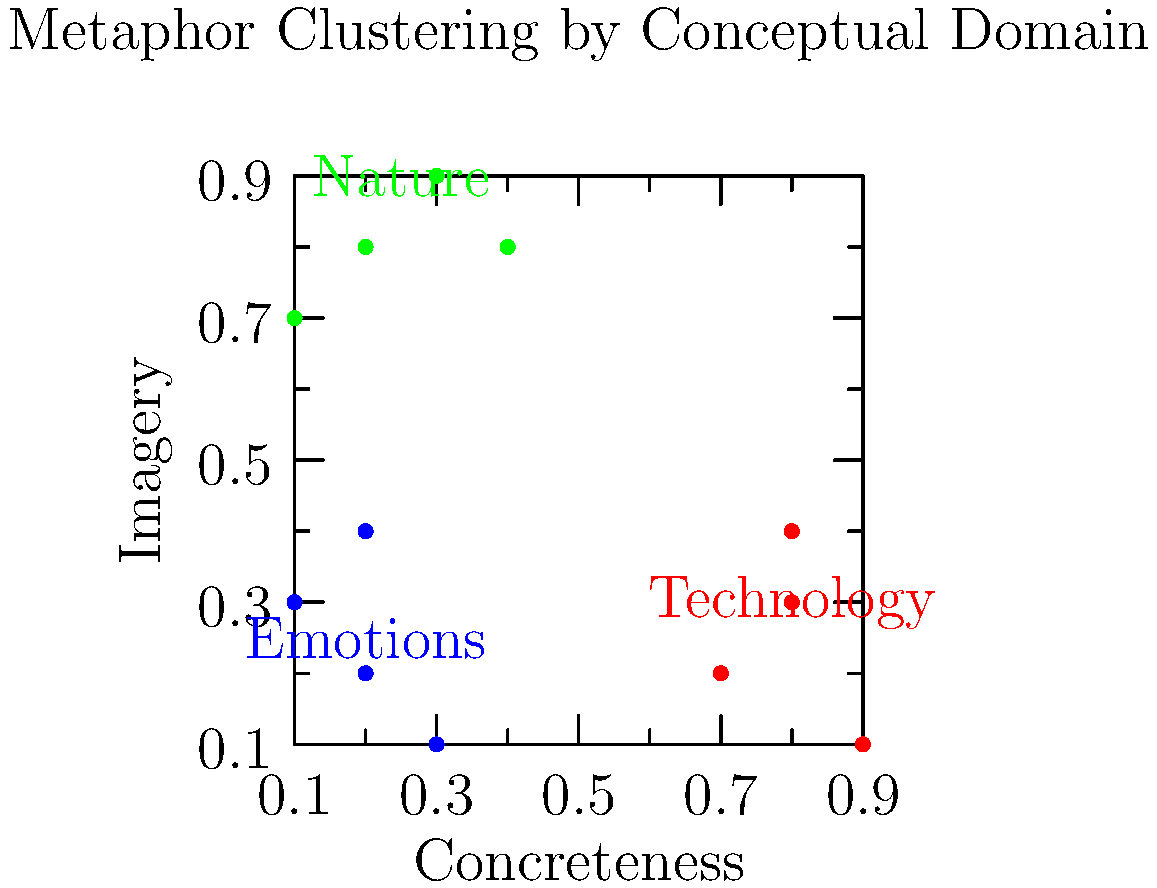Analyze the scatter plot depicting metaphor clustering based on conceptual domains. Which domain shows the highest degree of imagery and concreteness, and what might this suggest about the nature of metaphors in this domain? To answer this question, we need to examine the scatter plot and interpret the data points for each conceptual domain:

1. Identify the axes:
   - X-axis represents Concreteness
   - Y-axis represents Imagery

2. Locate the clusters:
   - Green cluster (top-left): Nature
   - Red cluster (bottom-right): Technology
   - Blue cluster (bottom-left): Emotions

3. Analyze the positioning of each cluster:
   - Nature: High imagery, relatively low concreteness
   - Technology: High concreteness, relatively low imagery
   - Emotions: Low in both imagery and concreteness

4. Determine the domain with highest imagery and concreteness:
   - Nature has the highest imagery
   - Technology has the highest concreteness
   - Neither domain scores highest in both dimensions simultaneously

5. Interpret the findings:
   - Nature metaphors tend to be highly visual but less tangible
   - Technology metaphors are more concrete but less imagistic
   - The nature domain shows the highest overall combination of imagery and concreteness

6. Consider the implications:
   - Nature metaphors may be more vivid and easier to visualize
   - This could suggest that nature-based metaphors are particularly effective in evoking mental images while still maintaining a degree of concreteness

Therefore, the nature domain shows the highest combined degree of imagery and concreteness, suggesting that nature-based metaphors may be particularly effective in creating vivid, relatable conceptual mappings.
Answer: Nature; suggests nature metaphors are vivid and relatable. 